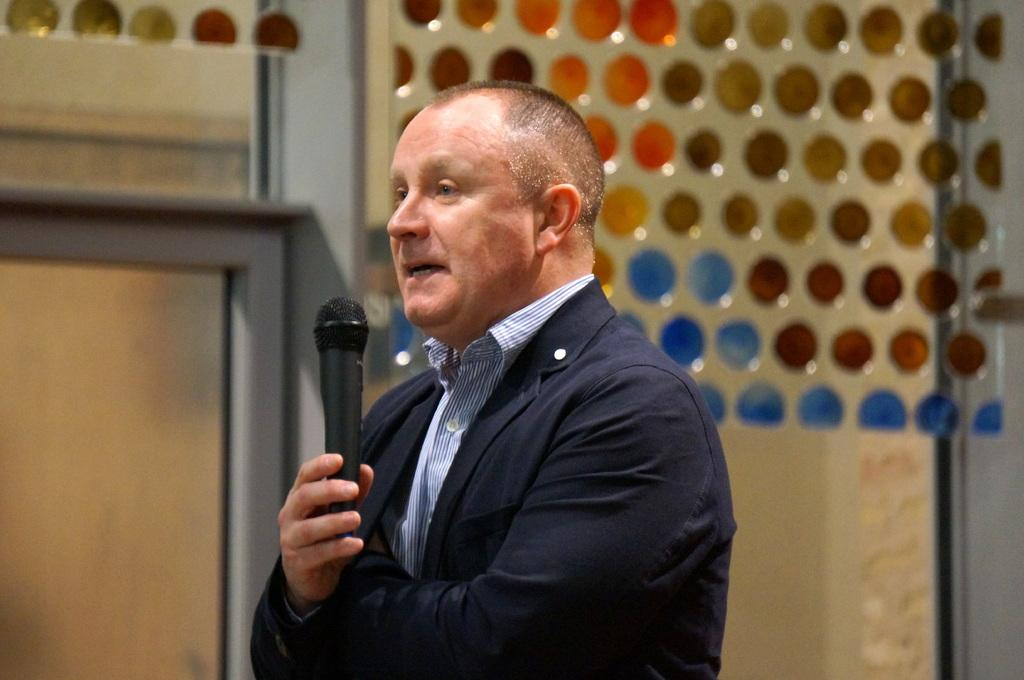Who or what is the main subject of the image? There is a person in the image. Can you describe the position of the person in the image? The person is standing in the center of the image. What is the person doing in the image? The person is speaking on a microphone. What type of quiver can be seen on the person's back in the image? There is no quiver present on the person's back in the image. Is the person standing in a wilderness setting in the image? The provided facts do not mention any wilderness setting, so we cannot determine the location from the image. 